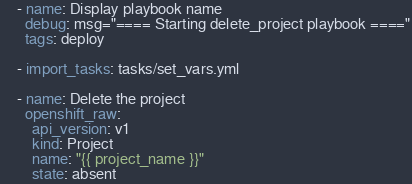<code> <loc_0><loc_0><loc_500><loc_500><_YAML_>    - name: Display playbook name
      debug: msg="==== Starting delete_project playbook ===="
      tags: deploy

    - import_tasks: tasks/set_vars.yml

    - name: Delete the project
      openshift_raw:
        api_version: v1
        kind: Project
        name: "{{ project_name }}"
        state: absent
</code> 